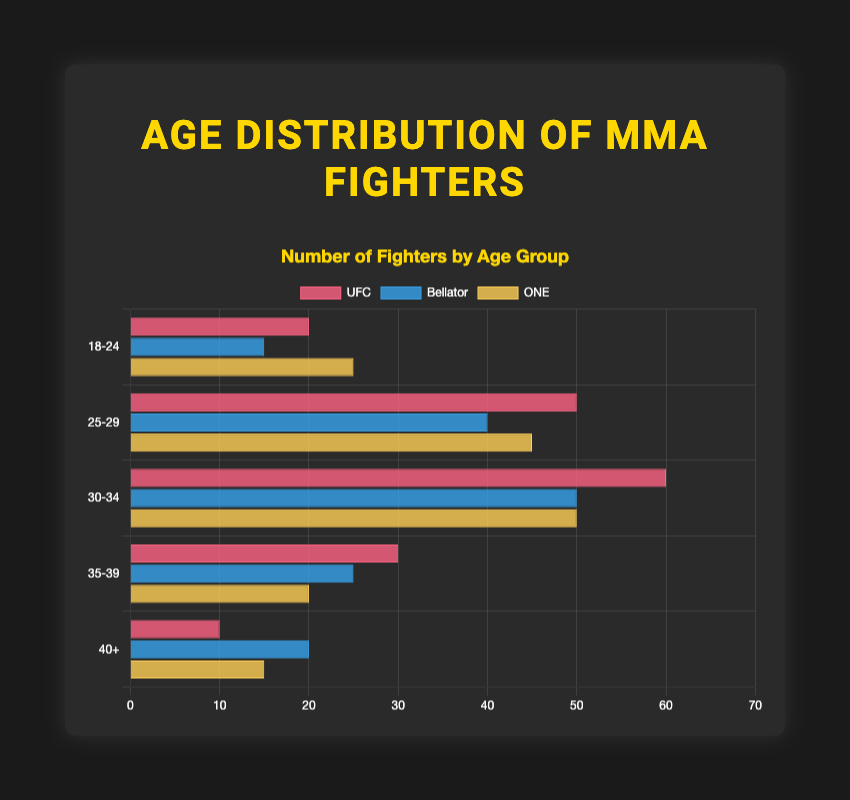What is the most common age group for UFC fighters? The UFC age distribution shows the highest number of fighters (60) in the 30-34 age group.
Answer: 30-34 Which league has the most fighters in the 40+ age group? By comparing the 40+ age bar lengths, Bellator has 20 fighters, UFC has 10, and ONE has 15.
Answer: Bellator How many fighters are there in total for Bellator? Summing up the fighters in all age groups for Bellator: 15 (18-24) + 40 (25-29) + 50 (30-34) + 25 (35-39) + 20 (40+) equals 150 fighters total.
Answer: 150 Which age group has the least number of fighters in ONE Championship? The 35-39 age group has the smallest bar for ONE with 20 fighters.
Answer: 35-39 How many more fighters are in the 25-29 age group in UFC compared to Bellator? UFC has 50 fighters in the 25-29 group, and Bellator has 40, so the difference is 50 - 40 = 10 fighters.
Answer: 10 Rank the age groups from most common to least common fighters for UFC. For UFC: 30-34 (60), 25-29 (50), 35-39 (30), 18-24 (20), 40+ (10).
Answer: 30-34, 25-29, 35-39, 18-24, 40+ What is the combined total of fighters aged 18-24 in all three leagues? Adding up the 18-24 fighters: UFC (20) + Bellator (15) + ONE (25) totals 20 + 15 + 25 = 60.
Answer: 60 Which league has the smallest sum of fighters in the 30-34 and 35-39 age categories combined? Summing for UFC: 60+30=90, Bellator: 50+25=75, ONE: 50+20=70. ONE has the smallest sum, 70.
Answer: ONE In which age group are the number of fighters the same for UFC and Bellator? Comparing age groups, the 30-34 groups are equal with 60 fighters each.
Answer: 30-34 How does the number of fighters aged 18-24 in ONE compare to UFC? ONE has 25 fighters aged 18-24, while UFC has 20; ONE has 5 more fighters in this age group.
Answer: ONE has more by 5 